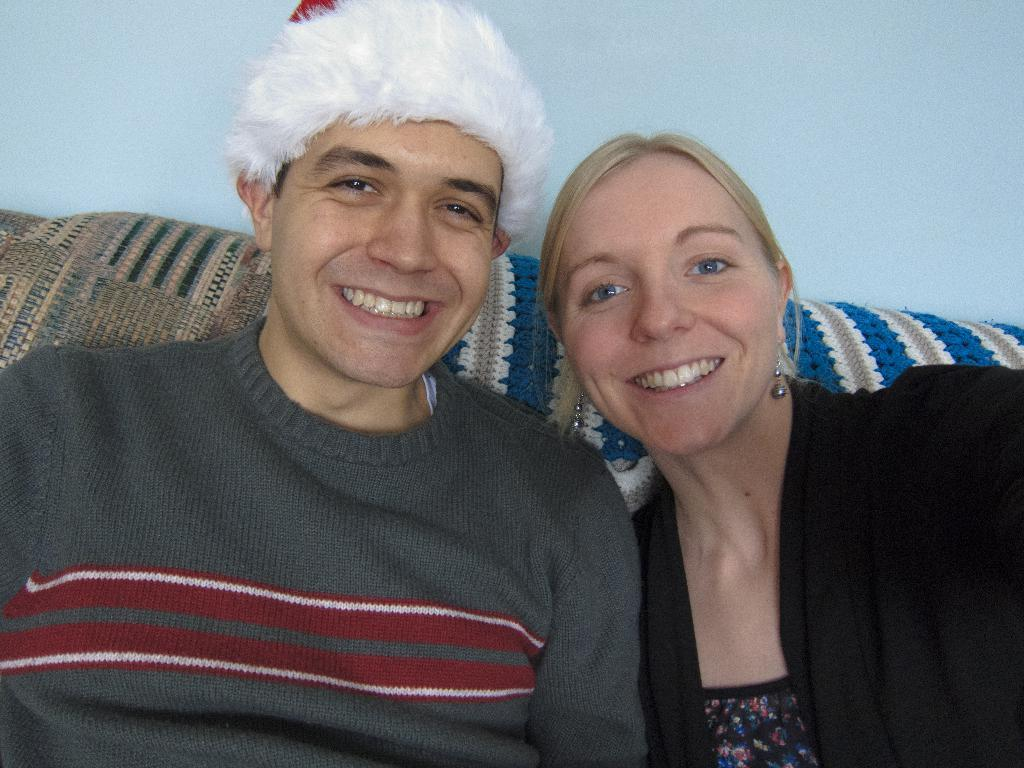How many people are in the image? There are two persons in the image. What are the persons doing in the image? The persons are sitting on a couch and smiling. What can be seen in the background of the image? There is a wall in the background of the image. Are the dolls crying in the image? There are no dolls present in the image, so it is not possible to determine if they are crying. 